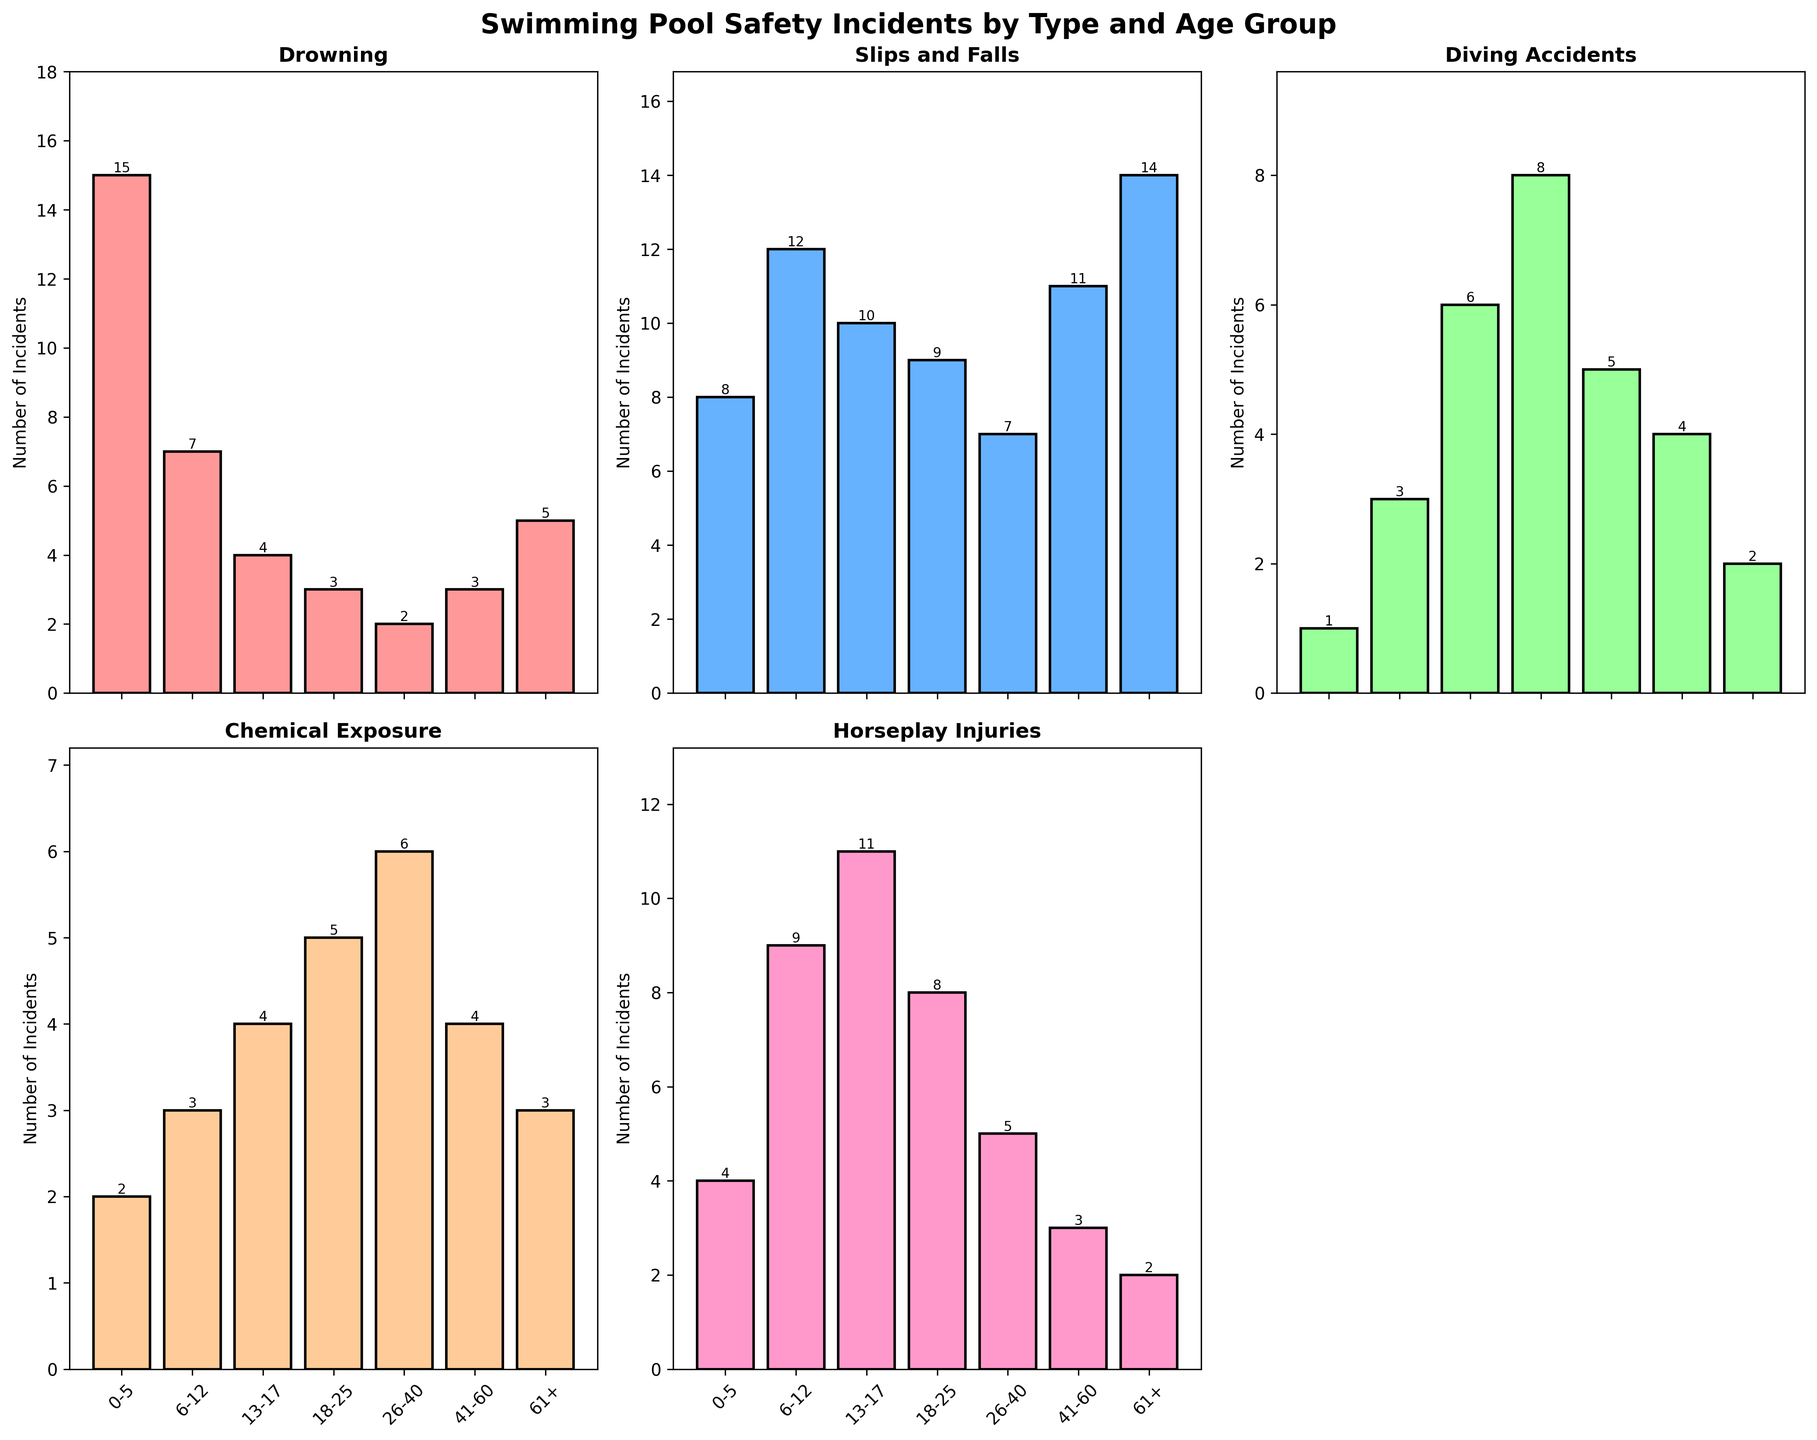Which age group experiences the most Chemical Exposure incidents? The figure shows the number of incidents for each age group. The '61+' age group has the highest bar in the subplot for Chemical Exposure.
Answer: 26-40 Which incident type has the highest number of occurrences for the 6-12 age group? Look at the bar heights for all incident types for the 6-12 age group. 'Slips and Falls' has the tallest bar among them.
Answer: Slips and Falls Are there more Drowning incidents in the 0-5 age group or Diving Accidents in the 18-25 age group? Compare the heights of the Drowning bar for the 0-5 age group with the Diving Accidents bar for the 18-25 age group. The 0-5 Drowning bar is taller.
Answer: 0-5 Drowning Which age group has the least Horseplay Injuries incidents? Observe the Horseplay Injuries subplot and identify the smallest bar. The '61+' age group has the shortest bar.
Answer: 61+ Calculate the total number of incidents for the 13-17 age group across all types. Sum the values for the 13-17 age group across all incident types: 4 (Drowning) + 10 (Slips and Falls) + 6 (Diving Accidents) + 4 (Chemical Exposure) + 11 (Horseplay Injuries) = 35.
Answer: 35 Which incident type generally decreases in number as the age increases? Look at the trend for each incident across age groups. Drowning incidents tend to decrease as age increases.
Answer: Drowning Compare the number of Slips and Falls incidents between the 41-60 and 61+ age groups. Which one is higher? Check the heights of bars for Slips and Falls for these age groups. The 61+ age group has a higher bar for Slips and Falls.
Answer: 61+ What is the combined number of Diving Accidents and Chemical Exposures incidents for the 18-25 age group? Add the values for Diving Accidents and Chemical Exposures for the 18-25 age group: 8 (Diving Accidents) + 5 (Chemical Exposure) = 13.
Answer: 13 In how many age groups are the Drowning incidents higher than 5? Count the age groups with Drowning incidents greater than 5. The 0-5, 6-12, and 61+ age groups fit this criterion.
Answer: 3 